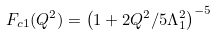<formula> <loc_0><loc_0><loc_500><loc_500>F _ { c 1 } ( Q ^ { 2 } ) = \left ( 1 + 2 Q ^ { 2 } / 5 \Lambda _ { 1 } ^ { 2 } \right ) ^ { - 5 }</formula> 